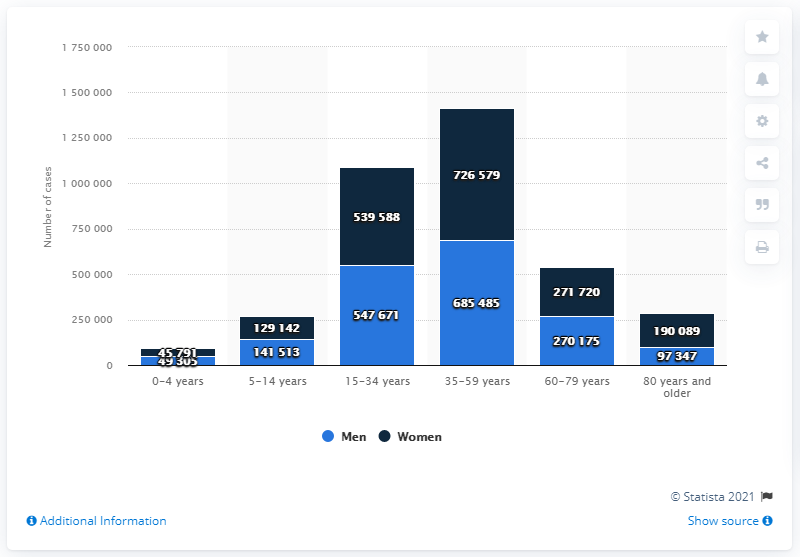Highlight a few significant elements in this photo. The 35-59 year age group was the most significantly impacted by the pandemic among men. 